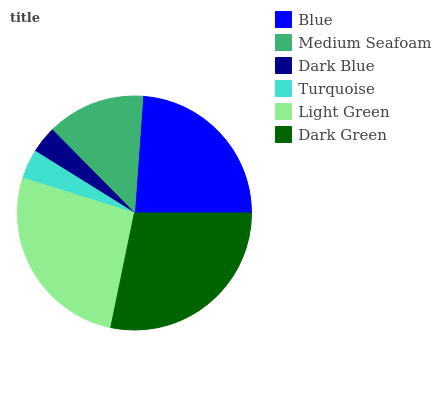Is Dark Blue the minimum?
Answer yes or no. Yes. Is Dark Green the maximum?
Answer yes or no. Yes. Is Medium Seafoam the minimum?
Answer yes or no. No. Is Medium Seafoam the maximum?
Answer yes or no. No. Is Blue greater than Medium Seafoam?
Answer yes or no. Yes. Is Medium Seafoam less than Blue?
Answer yes or no. Yes. Is Medium Seafoam greater than Blue?
Answer yes or no. No. Is Blue less than Medium Seafoam?
Answer yes or no. No. Is Blue the high median?
Answer yes or no. Yes. Is Medium Seafoam the low median?
Answer yes or no. Yes. Is Dark Blue the high median?
Answer yes or no. No. Is Dark Blue the low median?
Answer yes or no. No. 